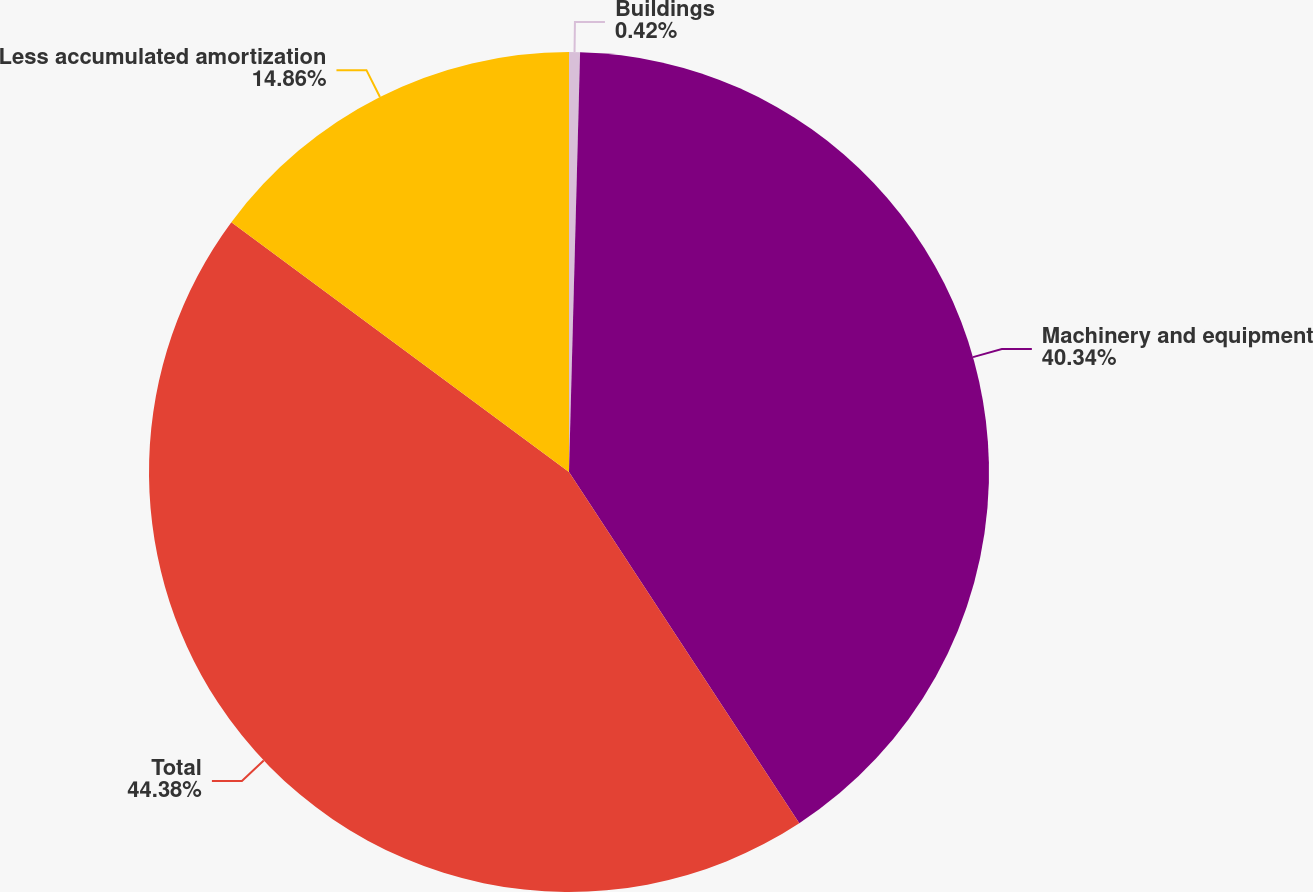Convert chart to OTSL. <chart><loc_0><loc_0><loc_500><loc_500><pie_chart><fcel>Buildings<fcel>Machinery and equipment<fcel>Total<fcel>Less accumulated amortization<nl><fcel>0.42%<fcel>40.34%<fcel>44.37%<fcel>14.86%<nl></chart> 